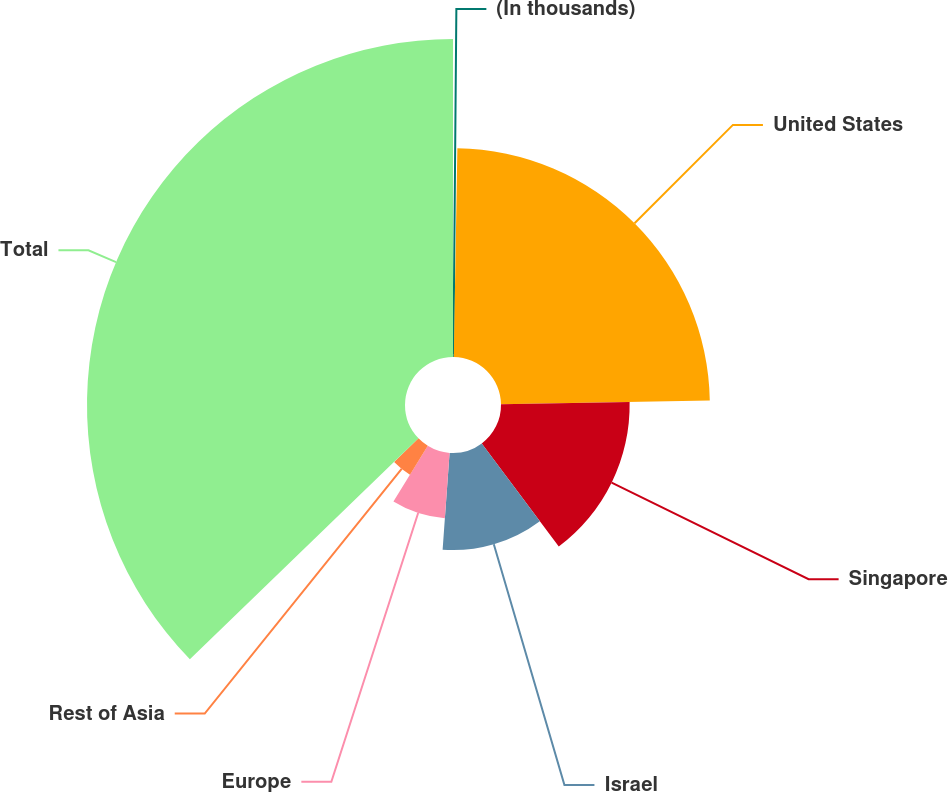Convert chart. <chart><loc_0><loc_0><loc_500><loc_500><pie_chart><fcel>(In thousands)<fcel>United States<fcel>Singapore<fcel>Israel<fcel>Europe<fcel>Rest of Asia<fcel>Total<nl><fcel>0.27%<fcel>24.45%<fcel>15.06%<fcel>11.36%<fcel>7.66%<fcel>3.97%<fcel>37.23%<nl></chart> 